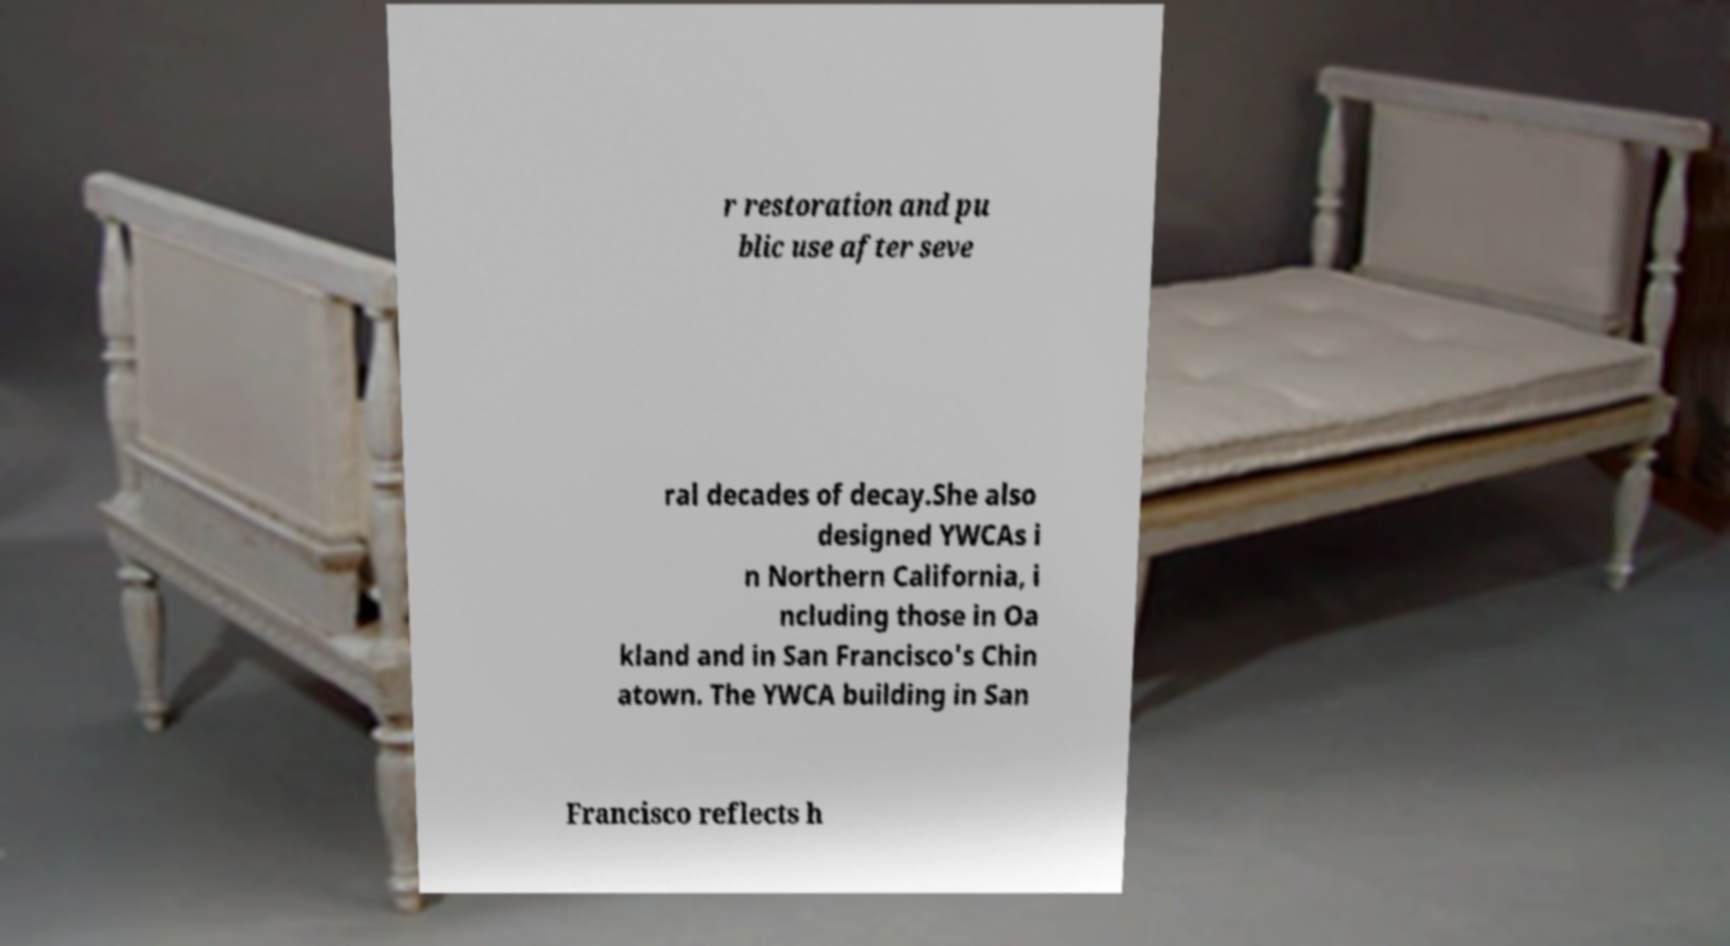Could you extract and type out the text from this image? r restoration and pu blic use after seve ral decades of decay.She also designed YWCAs i n Northern California, i ncluding those in Oa kland and in San Francisco's Chin atown. The YWCA building in San Francisco reflects h 